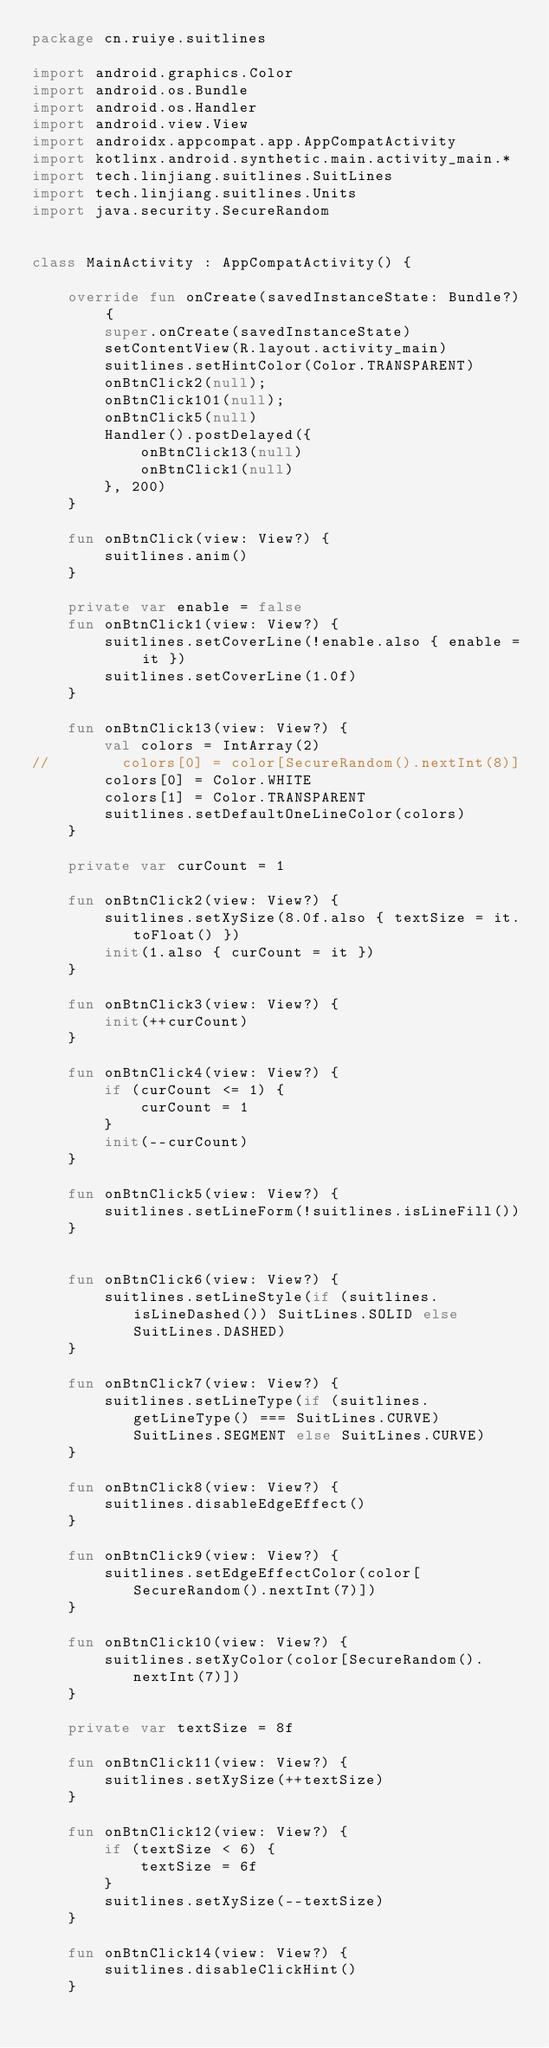Convert code to text. <code><loc_0><loc_0><loc_500><loc_500><_Kotlin_>package cn.ruiye.suitlines

import android.graphics.Color
import android.os.Bundle
import android.os.Handler
import android.view.View
import androidx.appcompat.app.AppCompatActivity
import kotlinx.android.synthetic.main.activity_main.*
import tech.linjiang.suitlines.SuitLines
import tech.linjiang.suitlines.Units
import java.security.SecureRandom


class MainActivity : AppCompatActivity() {

    override fun onCreate(savedInstanceState: Bundle?) {
        super.onCreate(savedInstanceState)
        setContentView(R.layout.activity_main)
        suitlines.setHintColor(Color.TRANSPARENT)
        onBtnClick2(null);
        onBtnClick101(null);
        onBtnClick5(null)
        Handler().postDelayed({
            onBtnClick13(null)
            onBtnClick1(null)
        }, 200)
    }

    fun onBtnClick(view: View?) {
        suitlines.anim()
    }

    private var enable = false
    fun onBtnClick1(view: View?) {
        suitlines.setCoverLine(!enable.also { enable = it })
        suitlines.setCoverLine(1.0f)
    }

    fun onBtnClick13(view: View?) {
        val colors = IntArray(2)
//        colors[0] = color[SecureRandom().nextInt(8)]
        colors[0] = Color.WHITE
        colors[1] = Color.TRANSPARENT
        suitlines.setDefaultOneLineColor(colors)
    }

    private var curCount = 1

    fun onBtnClick2(view: View?) {
        suitlines.setXySize(8.0f.also { textSize = it.toFloat() })
        init(1.also { curCount = it })
    }

    fun onBtnClick3(view: View?) {
        init(++curCount)
    }

    fun onBtnClick4(view: View?) {
        if (curCount <= 1) {
            curCount = 1
        }
        init(--curCount)
    }

    fun onBtnClick5(view: View?) {
        suitlines.setLineForm(!suitlines.isLineFill())
    }


    fun onBtnClick6(view: View?) {
        suitlines.setLineStyle(if (suitlines.isLineDashed()) SuitLines.SOLID else SuitLines.DASHED)
    }

    fun onBtnClick7(view: View?) {
        suitlines.setLineType(if (suitlines.getLineType() === SuitLines.CURVE) SuitLines.SEGMENT else SuitLines.CURVE)
    }

    fun onBtnClick8(view: View?) {
        suitlines.disableEdgeEffect()
    }

    fun onBtnClick9(view: View?) {
        suitlines.setEdgeEffectColor(color[SecureRandom().nextInt(7)])
    }

    fun onBtnClick10(view: View?) {
        suitlines.setXyColor(color[SecureRandom().nextInt(7)])
    }

    private var textSize = 8f

    fun onBtnClick11(view: View?) {
        suitlines.setXySize(++textSize)
    }

    fun onBtnClick12(view: View?) {
        if (textSize < 6) {
            textSize = 6f
        }
        suitlines.setXySize(--textSize)
    }

    fun onBtnClick14(view: View?) {
        suitlines.disableClickHint()
    }
</code> 